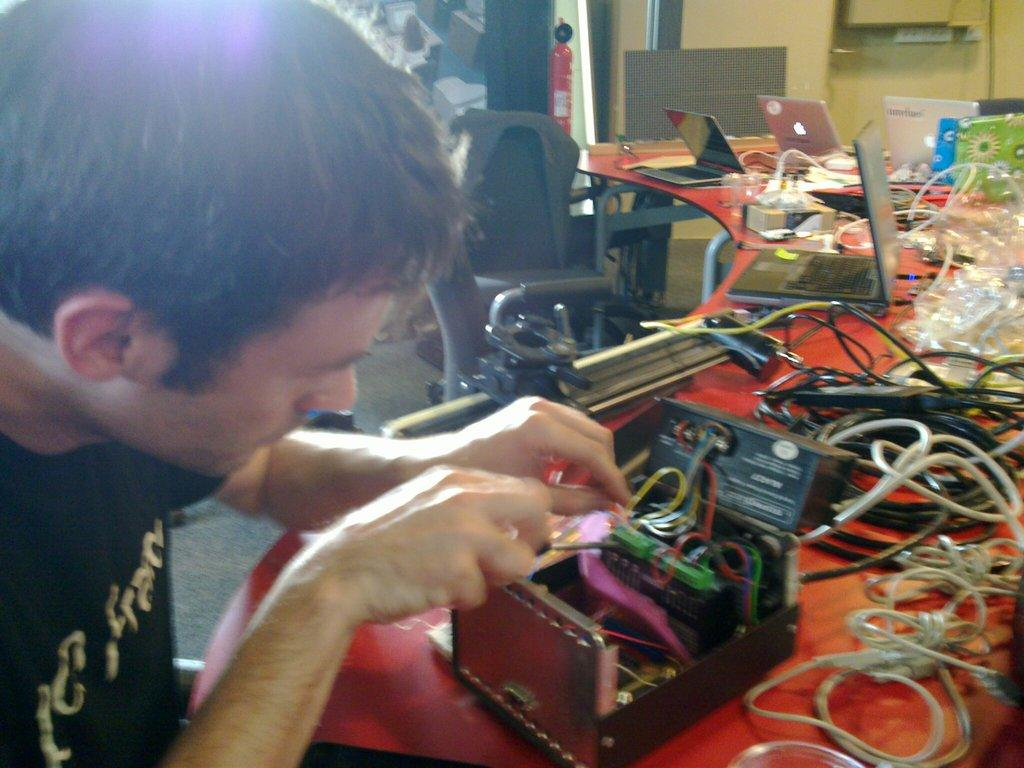What is the person in the image wearing? The person in the image is wearing a black t-shirt. What can be seen in the background of the image? There is a wall in the image. What type of furniture is present in the image? There is a chair and a table in the image. What is on the table in the image? There are wires, a laptop, a box, and some electrical equipment on the table. How many muscles can be seen flexing in the image? There are no muscles visible in the image, as it features a person wearing a black t-shirt and various objects on a table. 